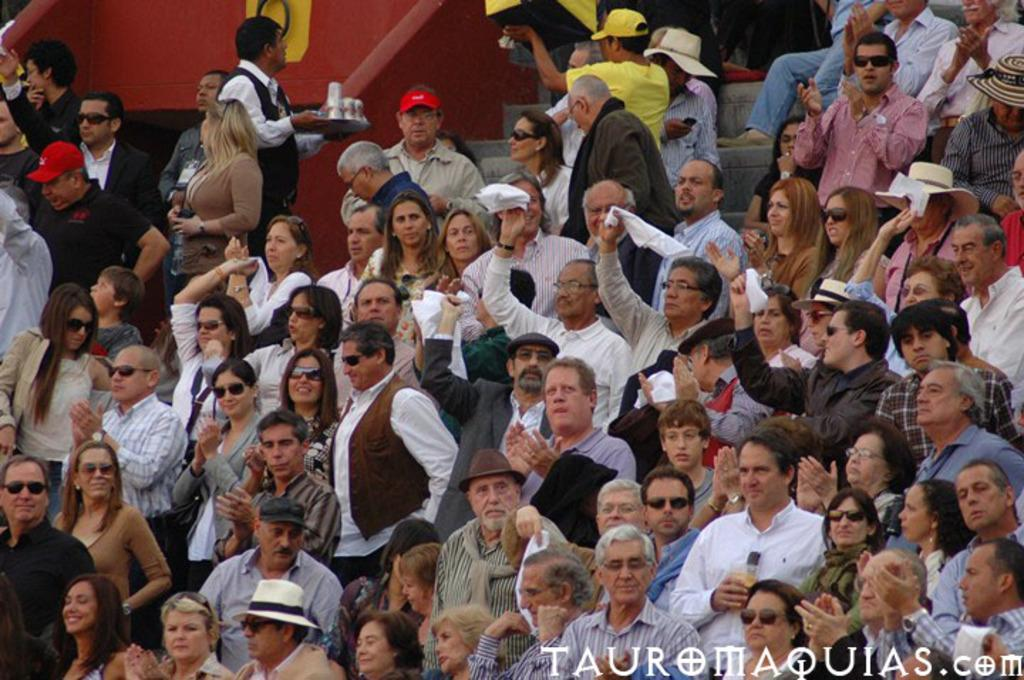What is happening with the group of people in the image? The people are standing and clapping in the image. Can you describe the position of the people in the image? The people are standing in the image. What is written at the bottom of the image? There is text written at the bottom of the image. What type of soap is being used by the people in the image? There is no soap present in the image; the people are clapping. What time of day is depicted in the image? The time of day is not mentioned in the image, so it cannot be determined. 